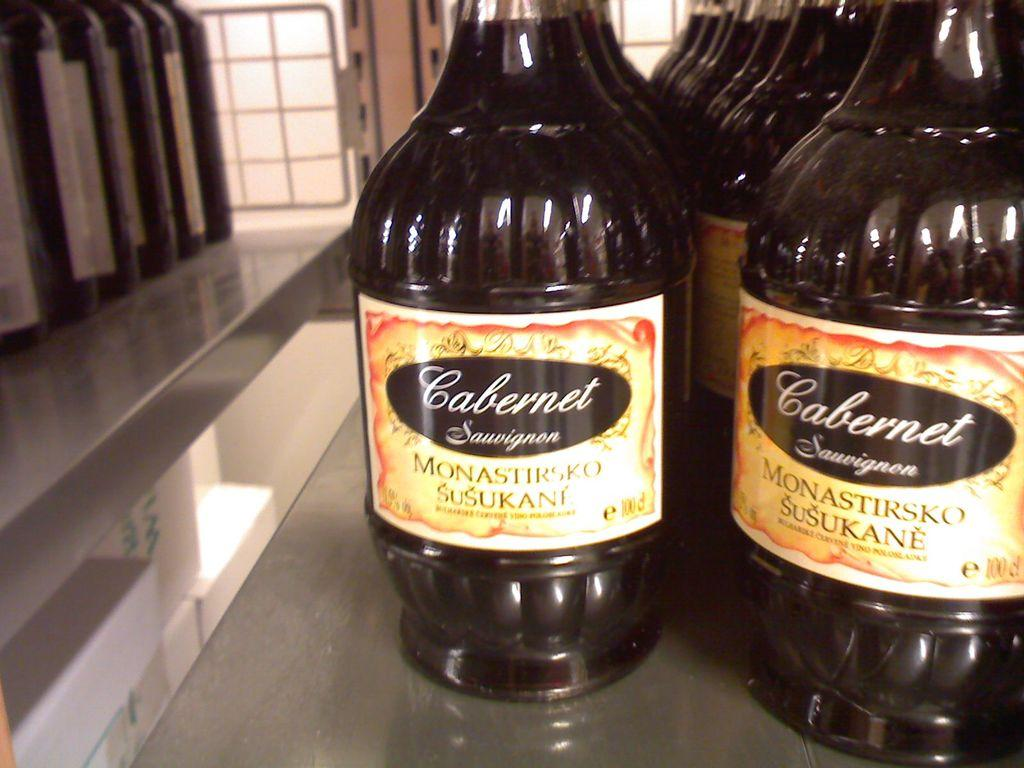Provide a one-sentence caption for the provided image. Monastirsko Susukane bottles Cabernet Sauvignon in glass bottles with brightly colored labels. 